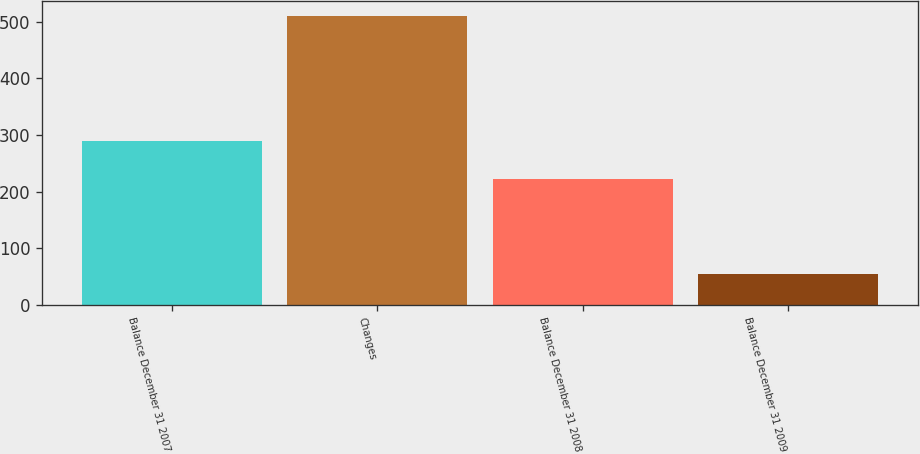Convert chart to OTSL. <chart><loc_0><loc_0><loc_500><loc_500><bar_chart><fcel>Balance December 31 2007<fcel>Changes<fcel>Balance December 31 2008<fcel>Balance December 31 2009<nl><fcel>289<fcel>511<fcel>222<fcel>55<nl></chart> 